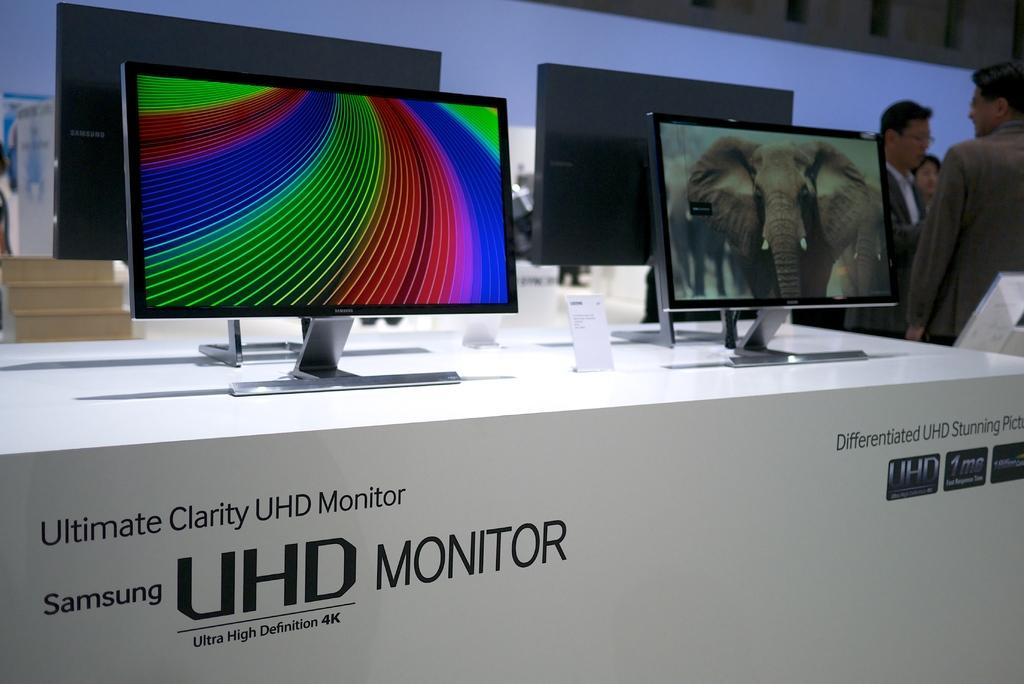Provide a one-sentence caption for the provided image. a box for the samsung uhd monitor and setup screens displayed on top. 